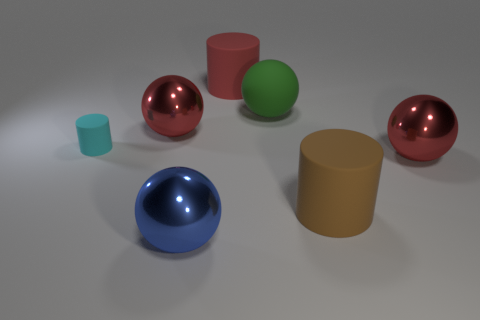Add 3 big red shiny things. How many objects exist? 10 Subtract all spheres. How many objects are left? 3 Add 6 large cylinders. How many large cylinders are left? 8 Add 7 metallic objects. How many metallic objects exist? 10 Subtract 1 cyan cylinders. How many objects are left? 6 Subtract all brown matte cylinders. Subtract all metallic spheres. How many objects are left? 3 